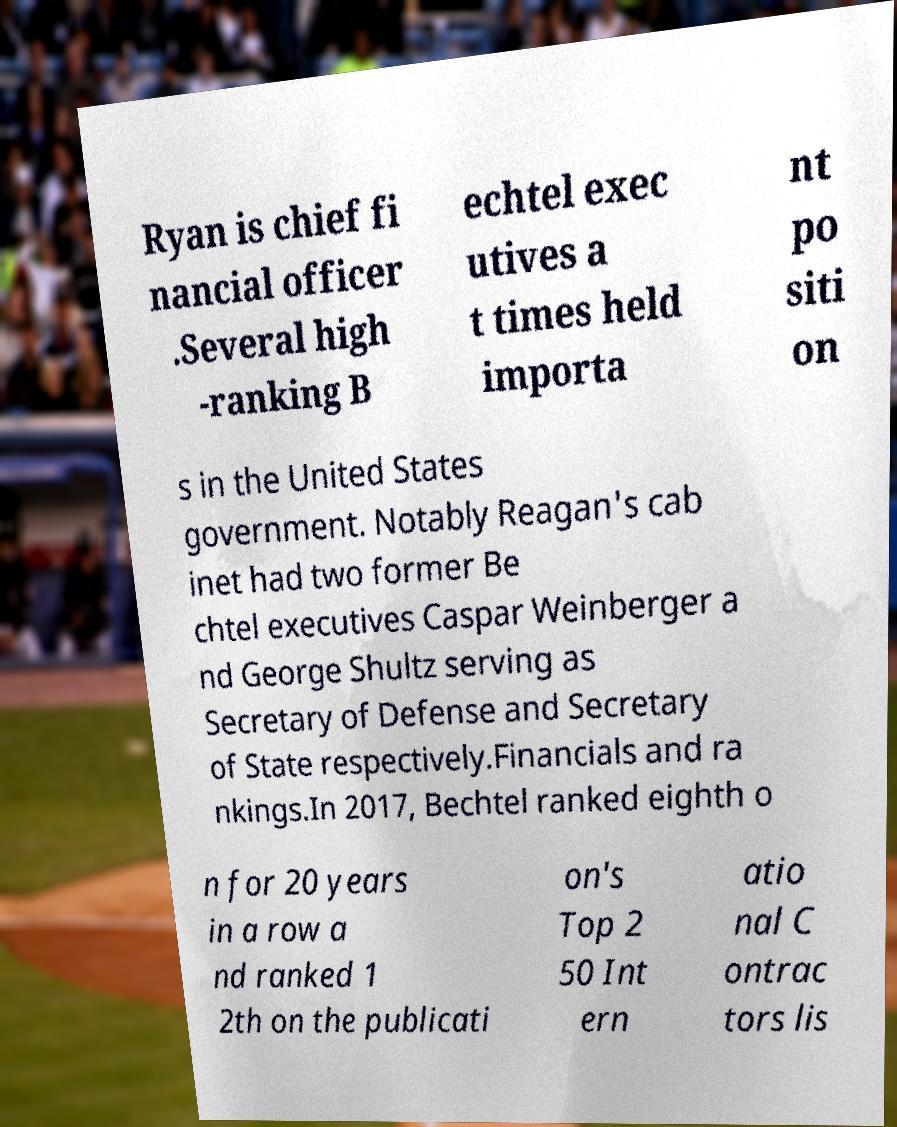Please read and relay the text visible in this image. What does it say? Ryan is chief fi nancial officer .Several high -ranking B echtel exec utives a t times held importa nt po siti on s in the United States government. Notably Reagan's cab inet had two former Be chtel executives Caspar Weinberger a nd George Shultz serving as Secretary of Defense and Secretary of State respectively.Financials and ra nkings.In 2017, Bechtel ranked eighth o n for 20 years in a row a nd ranked 1 2th on the publicati on's Top 2 50 Int ern atio nal C ontrac tors lis 